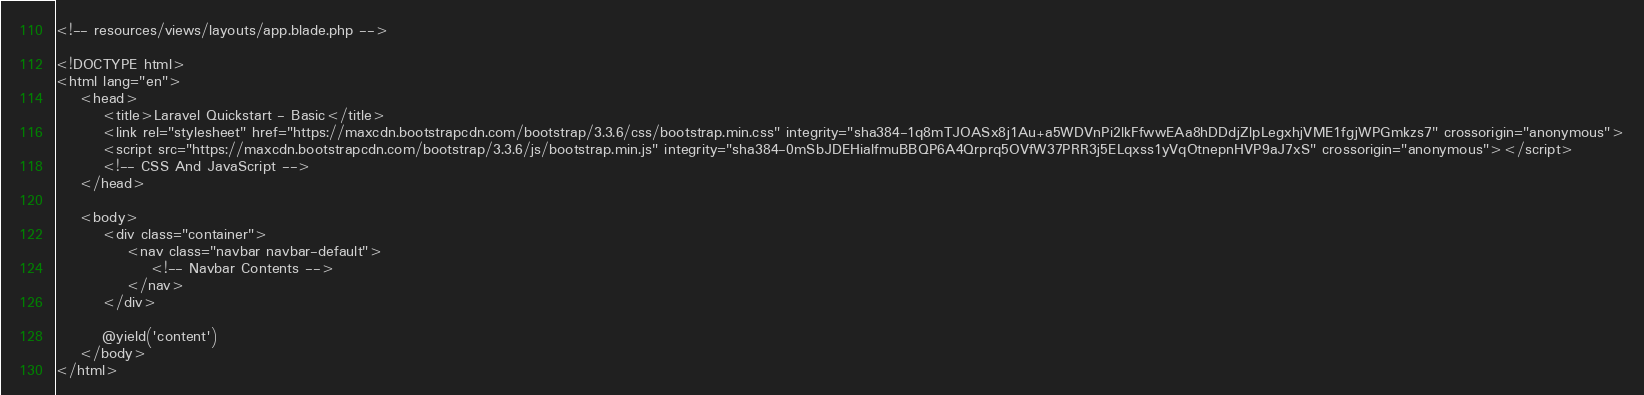Convert code to text. <code><loc_0><loc_0><loc_500><loc_500><_PHP_><!-- resources/views/layouts/app.blade.php -->

<!DOCTYPE html>
<html lang="en">
    <head>
        <title>Laravel Quickstart - Basic</title>
        <link rel="stylesheet" href="https://maxcdn.bootstrapcdn.com/bootstrap/3.3.6/css/bootstrap.min.css" integrity="sha384-1q8mTJOASx8j1Au+a5WDVnPi2lkFfwwEAa8hDDdjZlpLegxhjVME1fgjWPGmkzs7" crossorigin="anonymous">
        <script src="https://maxcdn.bootstrapcdn.com/bootstrap/3.3.6/js/bootstrap.min.js" integrity="sha384-0mSbJDEHialfmuBBQP6A4Qrprq5OVfW37PRR3j5ELqxss1yVqOtnepnHVP9aJ7xS" crossorigin="anonymous"></script>
        <!-- CSS And JavaScript -->
    </head>

    <body>
        <div class="container">
            <nav class="navbar navbar-default">
                <!-- Navbar Contents -->
            </nav>
        </div>

        @yield('content')
    </body>
</html></code> 